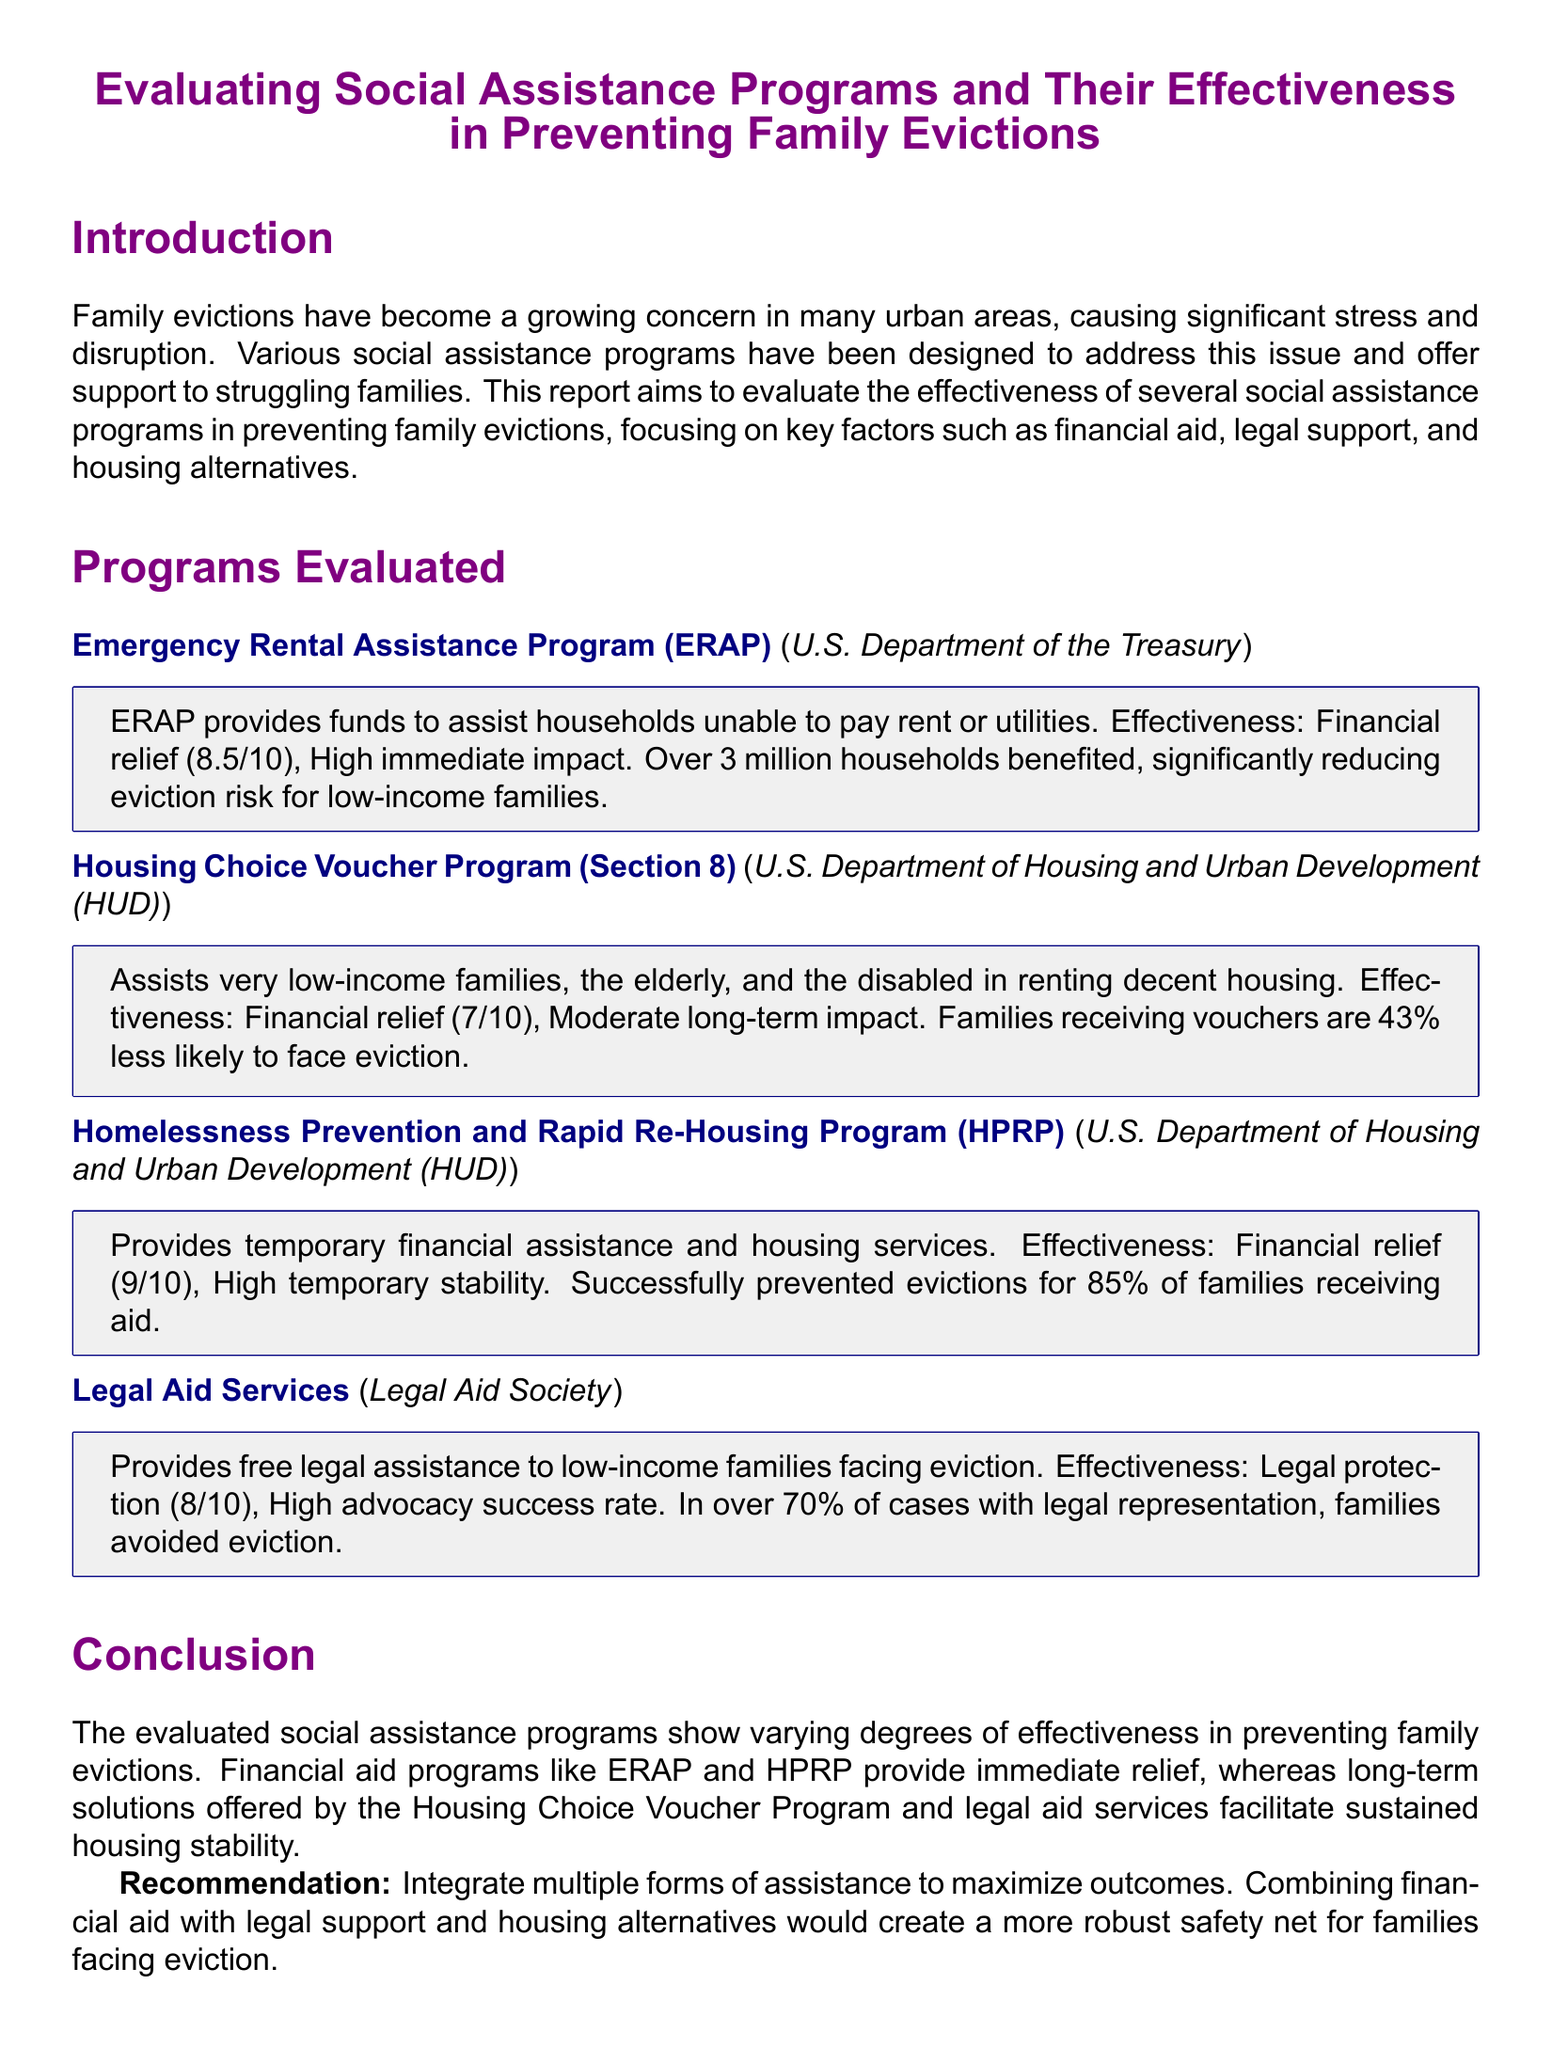what is the title of the report? The title of the report is explicitly stated at the beginning.
Answer: Evaluating Social Assistance Programs and Their Effectiveness in Preventing Family Evictions who administers the Emergency Rental Assistance Program? The document specifies that the program is administered by the U.S. Department of the Treasury.
Answer: U.S. Department of the Treasury what percentage of families receiving aid from HPRP avoided eviction? The report mentions a specific success rate for families receiving aid under HPRP.
Answer: 85% what is the effectiveness rating for the Housing Choice Voucher Program? The effectiveness rating is explicitly listed in the program evaluation section of the report.
Answer: 7/10 which program provides free legal assistance to low-income families? The report states which program offers legal aid to families facing eviction.
Answer: Legal Aid Services what is a recommended approach for maximizing outcomes in preventing evictions? The conclusion section contains recommendations related to assistance integration.
Answer: Integrate multiple forms of assistance what type of impact does the Emergency Rental Assistance Program have? The document categorizes the impact of the program in its evaluation section.
Answer: High immediate impact how many households benefited from the Emergency Rental Assistance Program? The report provides a specific number of households that received assistance.
Answer: Over 3 million households 